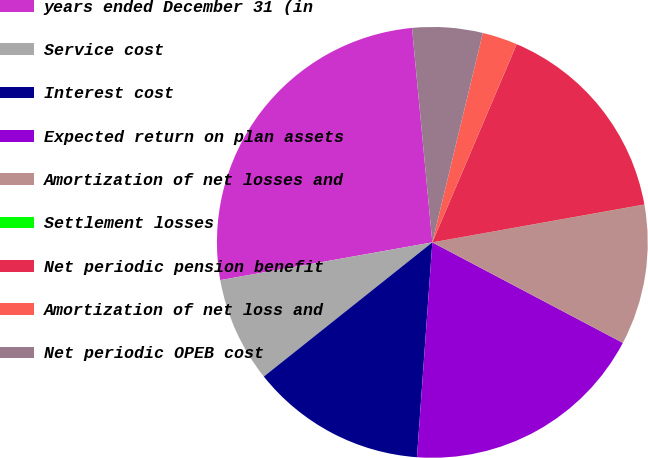Convert chart to OTSL. <chart><loc_0><loc_0><loc_500><loc_500><pie_chart><fcel>years ended December 31 (in<fcel>Service cost<fcel>Interest cost<fcel>Expected return on plan assets<fcel>Amortization of net losses and<fcel>Settlement losses<fcel>Net periodic pension benefit<fcel>Amortization of net loss and<fcel>Net periodic OPEB cost<nl><fcel>26.3%<fcel>7.9%<fcel>13.16%<fcel>18.41%<fcel>10.53%<fcel>0.01%<fcel>15.78%<fcel>2.64%<fcel>5.27%<nl></chart> 